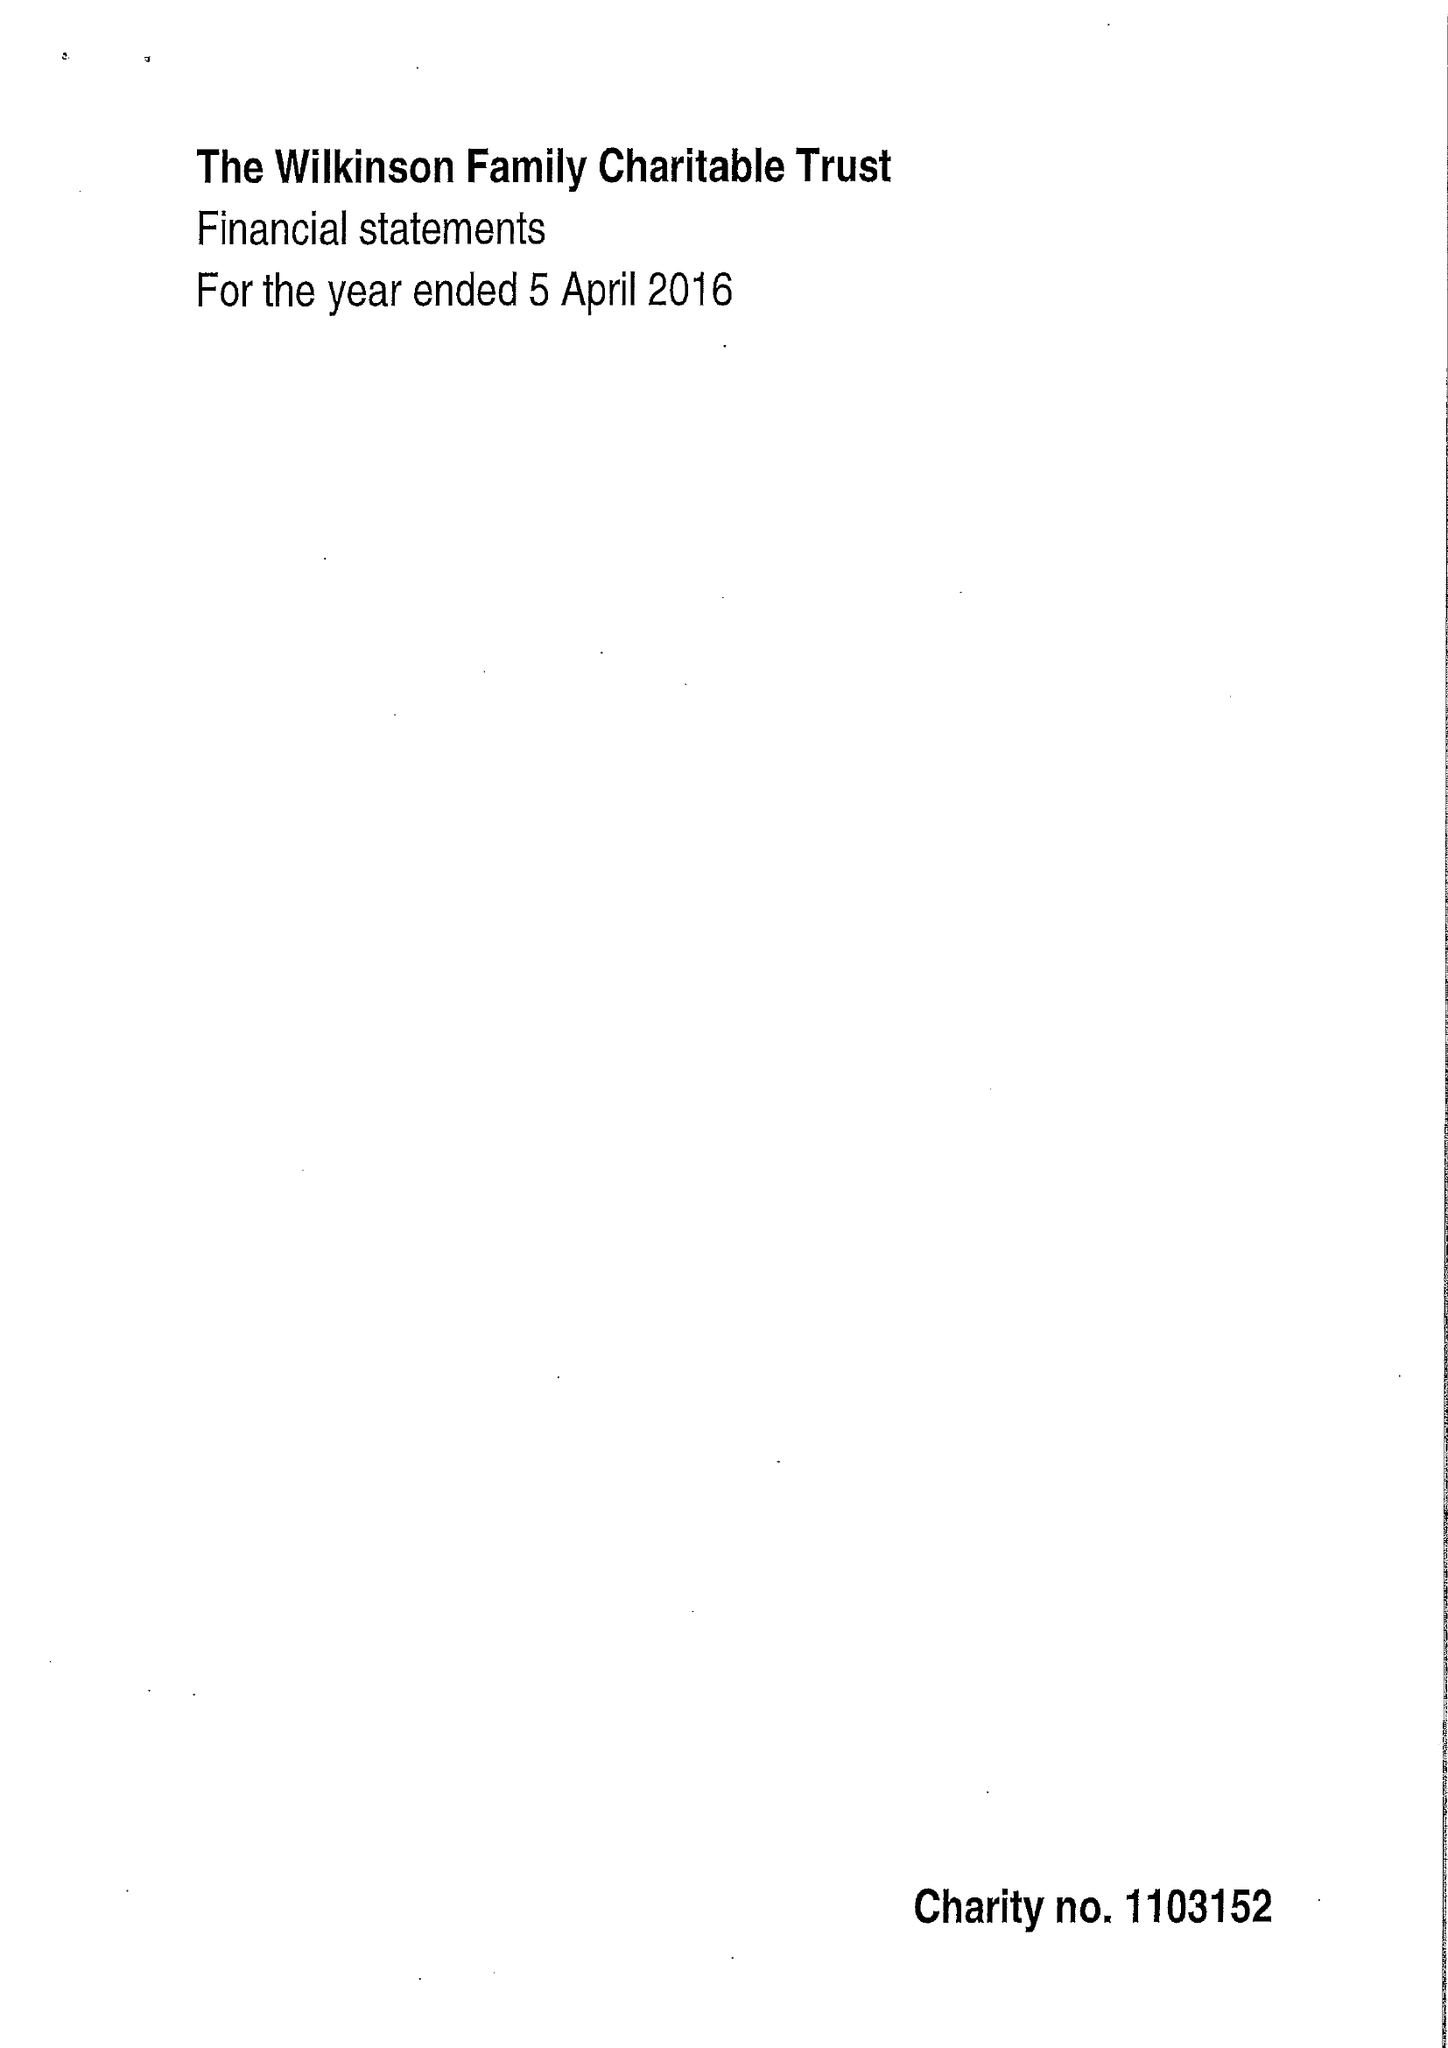What is the value for the report_date?
Answer the question using a single word or phrase. 2016-04-05 